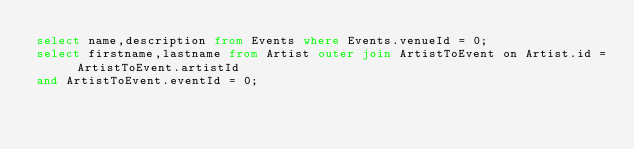<code> <loc_0><loc_0><loc_500><loc_500><_SQL_>select name,description from Events where Events.venueId = 0;
select firstname,lastname from Artist outer join ArtistToEvent on Artist.id = ArtistToEvent.artistId
and ArtistToEvent.eventId = 0;</code> 